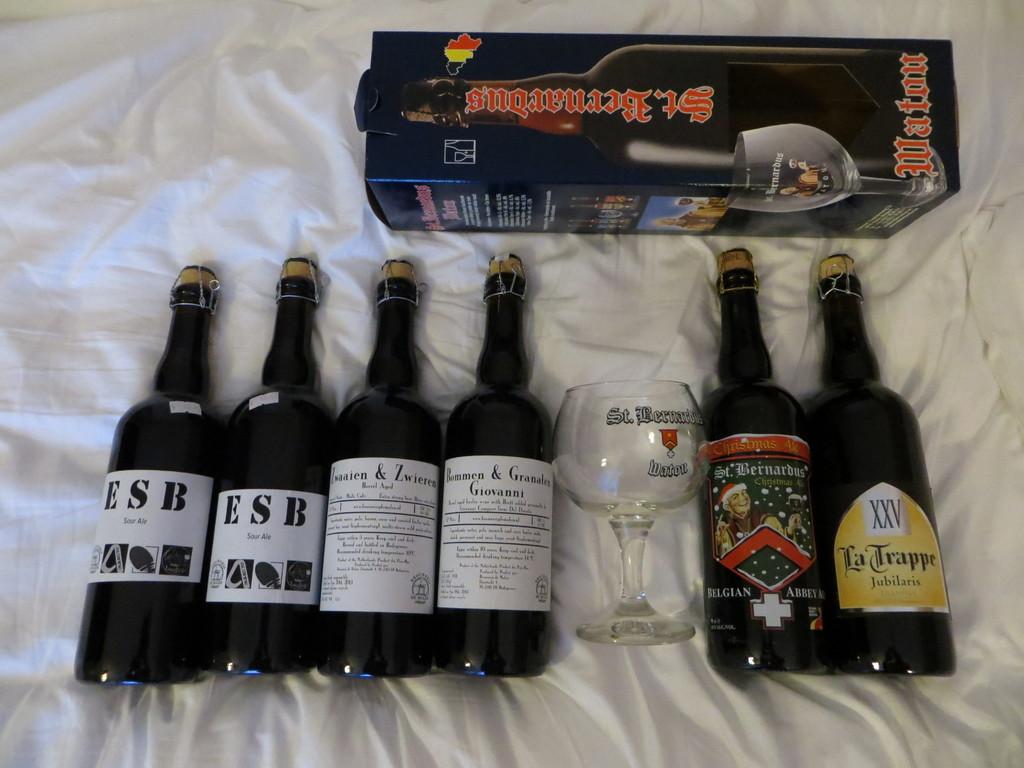What are the three letters on the bottle on the far left?
Make the answer very short. Esb. What's the name of the beer in the box on top?
Provide a succinct answer. St. bernardus. 